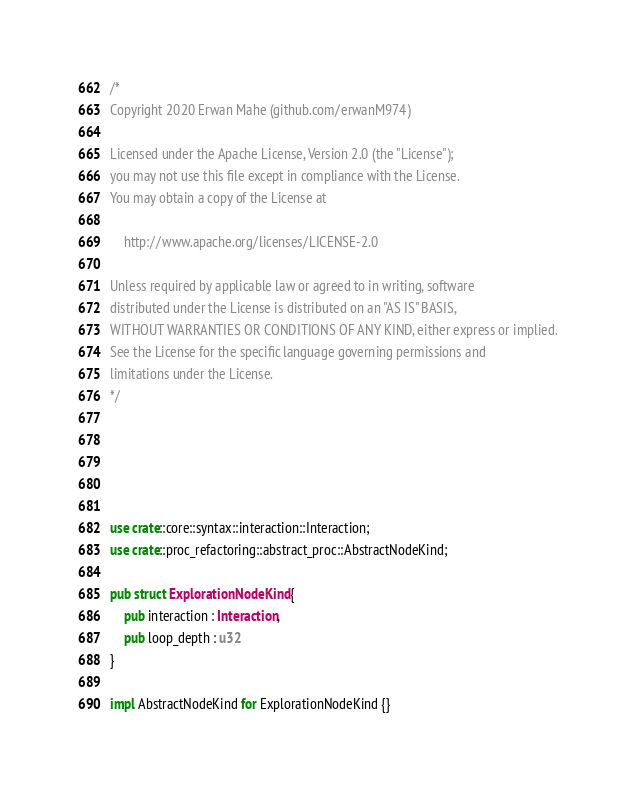<code> <loc_0><loc_0><loc_500><loc_500><_Rust_>/*
Copyright 2020 Erwan Mahe (github.com/erwanM974)

Licensed under the Apache License, Version 2.0 (the "License");
you may not use this file except in compliance with the License.
You may obtain a copy of the License at

    http://www.apache.org/licenses/LICENSE-2.0

Unless required by applicable law or agreed to in writing, software
distributed under the License is distributed on an "AS IS" BASIS,
WITHOUT WARRANTIES OR CONDITIONS OF ANY KIND, either express or implied.
See the License for the specific language governing permissions and
limitations under the License.
*/





use crate::core::syntax::interaction::Interaction;
use crate::proc_refactoring::abstract_proc::AbstractNodeKind;

pub struct ExplorationNodeKind {
    pub interaction : Interaction,
    pub loop_depth : u32
}

impl AbstractNodeKind for ExplorationNodeKind {}

</code> 